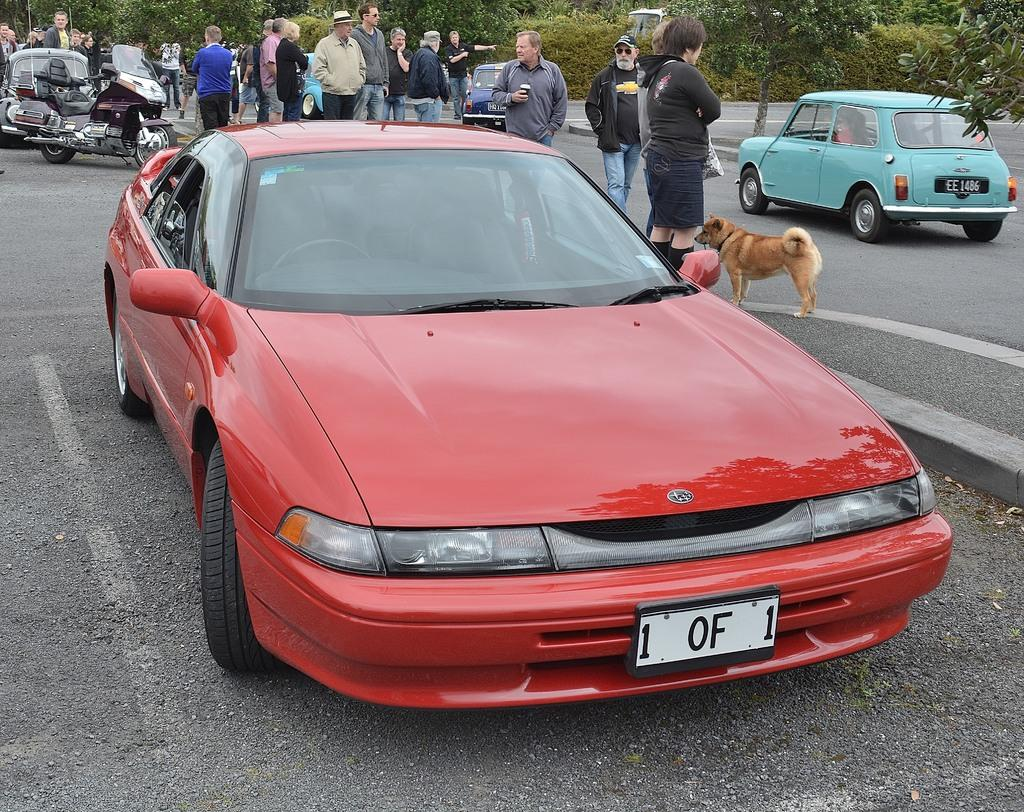What types of objects are present in the image? There are vehicles, a dog, and a group of people in the image. Where are the group of people located? The group of people is on the road in the image. What can be seen in the background of the image? There are trees in the background of the image. How many pizzas are being carried by the dog in the image? There are no pizzas present in the image; it features a dog along with vehicles and a group of people. What trick is the dog performing in the image? There is no trick being performed by the dog in the image; it is simply present alongside the other subjects. 